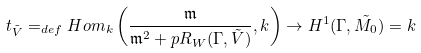Convert formula to latex. <formula><loc_0><loc_0><loc_500><loc_500>t _ { \tilde { V } } = _ { d e f } H o m _ { k } \left ( \frac { \mathfrak { m } } { \mathfrak { m } ^ { 2 } + p R _ { W } ( \Gamma , \tilde { V } ) } , k \right ) \to H ^ { 1 } ( \Gamma , \tilde { M _ { 0 } } ) = k</formula> 